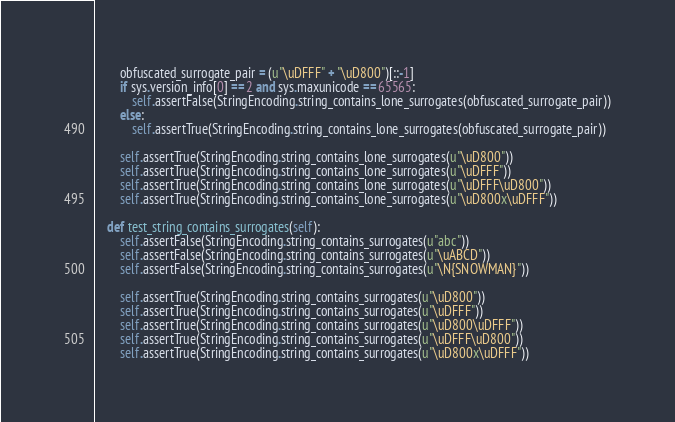Convert code to text. <code><loc_0><loc_0><loc_500><loc_500><_Python_>        obfuscated_surrogate_pair = (u"\uDFFF" + "\uD800")[::-1]
        if sys.version_info[0] == 2 and sys.maxunicode == 65565:
            self.assertFalse(StringEncoding.string_contains_lone_surrogates(obfuscated_surrogate_pair))
        else:
            self.assertTrue(StringEncoding.string_contains_lone_surrogates(obfuscated_surrogate_pair))

        self.assertTrue(StringEncoding.string_contains_lone_surrogates(u"\uD800"))
        self.assertTrue(StringEncoding.string_contains_lone_surrogates(u"\uDFFF"))
        self.assertTrue(StringEncoding.string_contains_lone_surrogates(u"\uDFFF\uD800"))
        self.assertTrue(StringEncoding.string_contains_lone_surrogates(u"\uD800x\uDFFF"))

    def test_string_contains_surrogates(self):
        self.assertFalse(StringEncoding.string_contains_surrogates(u"abc"))
        self.assertFalse(StringEncoding.string_contains_surrogates(u"\uABCD"))
        self.assertFalse(StringEncoding.string_contains_surrogates(u"\N{SNOWMAN}"))

        self.assertTrue(StringEncoding.string_contains_surrogates(u"\uD800"))
        self.assertTrue(StringEncoding.string_contains_surrogates(u"\uDFFF"))
        self.assertTrue(StringEncoding.string_contains_surrogates(u"\uD800\uDFFF"))
        self.assertTrue(StringEncoding.string_contains_surrogates(u"\uDFFF\uD800"))
        self.assertTrue(StringEncoding.string_contains_surrogates(u"\uD800x\uDFFF"))
</code> 